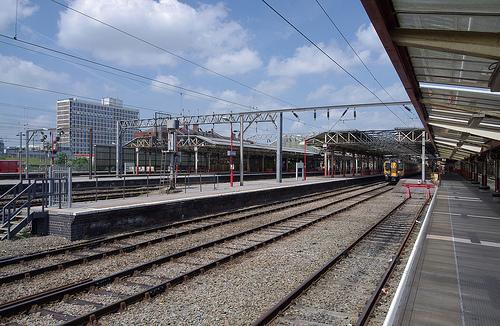Imagine a story taking place in this scene. Briefly describe it. As the yellow train pulls into the downtown subway station, a young traveler sits on the small red bench, contemplating the adventures to come in the large white building towering in the distance. What is the function of the overhang in the image and its color? The function of the overhang is to cover the railway platform and its color is light gray. What type of location can this image be described as? A subway downtown during the day time. List three objects in the picture that have a color in their description. A small red bench, a yellow train car, and a red barricade. What is the dominant architectural feature in the image and its color? A multistorey white building. What color is the sky in the image and are there any clouds? The sky is blue with white clouds. Identify the primary mode of transportation depicted in the image. A yellow train on the tracks. Which elements of the image indicate that this is a railway station? Train tracks, yellow train car, railway platform, and railway station cover. Provide a poetic description of the scene. Amidst a blue sky with ivory clouds, the yellow train car glides upon dark brown tracks, accompanied by a red bench and a white building standing tall in the distance. Describe the surroundings of the dark brown train tracks. There's a light grey railway platform, some gray gravel, a red barricade, a gray cement sidewalk, and red poles near the tracks. 